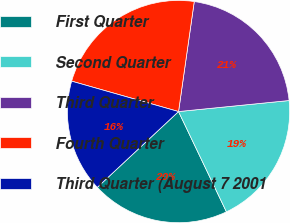<chart> <loc_0><loc_0><loc_500><loc_500><pie_chart><fcel>First Quarter<fcel>Second Quarter<fcel>Third Quarter<fcel>Fourth Quarter<fcel>Third Quarter (August 7 2001<nl><fcel>20.14%<fcel>19.49%<fcel>21.16%<fcel>22.85%<fcel>16.36%<nl></chart> 